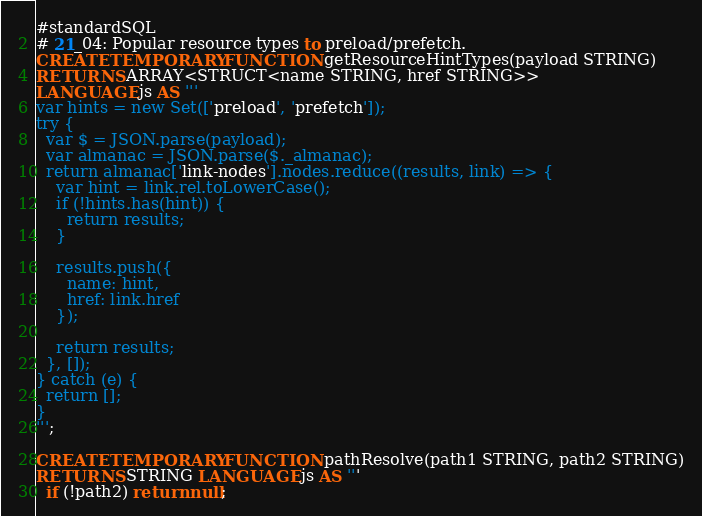Convert code to text. <code><loc_0><loc_0><loc_500><loc_500><_SQL_>#standardSQL
# 21_04: Popular resource types to preload/prefetch.
CREATE TEMPORARY FUNCTION getResourceHintTypes(payload STRING)
RETURNS ARRAY<STRUCT<name STRING, href STRING>>
LANGUAGE js AS '''
var hints = new Set(['preload', 'prefetch']);
try {
  var $ = JSON.parse(payload);
  var almanac = JSON.parse($._almanac);
  return almanac['link-nodes'].nodes.reduce((results, link) => {
    var hint = link.rel.toLowerCase();
    if (!hints.has(hint)) {
      return results;
    }

    results.push({
      name: hint,
      href: link.href
    });

    return results;
  }, []);
} catch (e) {
  return [];
}
''';

CREATE TEMPORARY FUNCTION pathResolve(path1 STRING, path2 STRING)
RETURNS STRING LANGUAGE js AS '''
  if (!path2) return null;</code> 